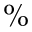Convert formula to latex. <formula><loc_0><loc_0><loc_500><loc_500>\%</formula> 